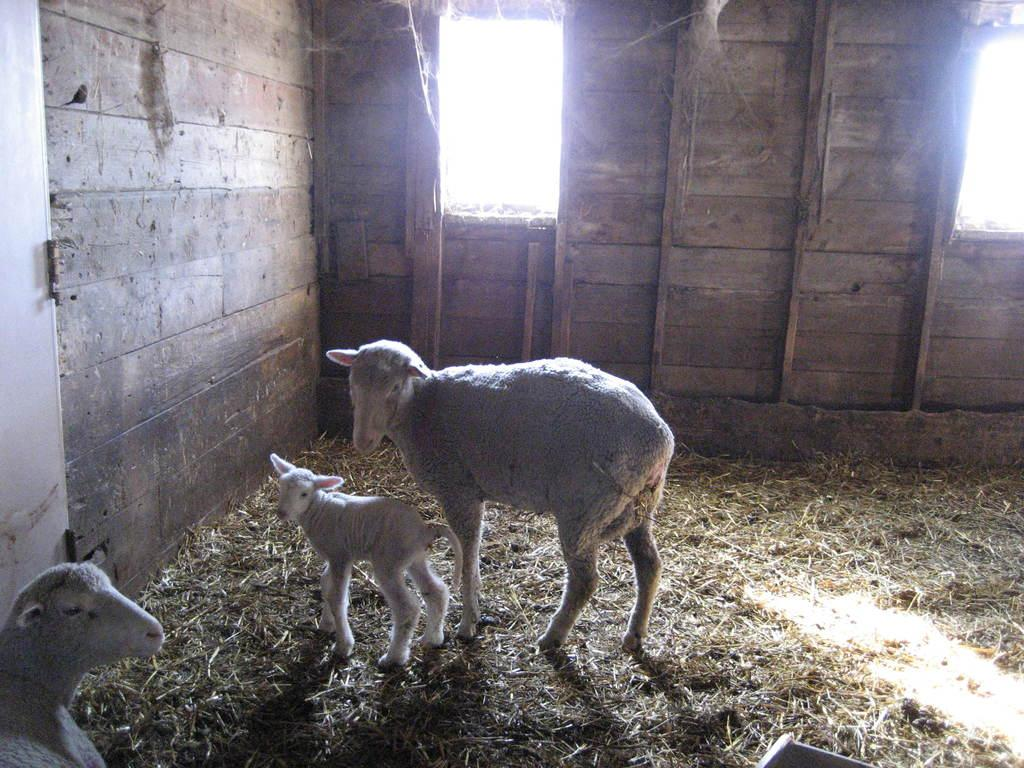How many animals are present in the image? There are three sheep in the image. Where are the sheep located? The sheep are inside a shed. What type of vegetation can be seen in the image? There is grass visible in the image. What type of jelly can be seen on the floor in the image? There is no jelly present in the image; it features three sheep inside a shed with grass visible. 